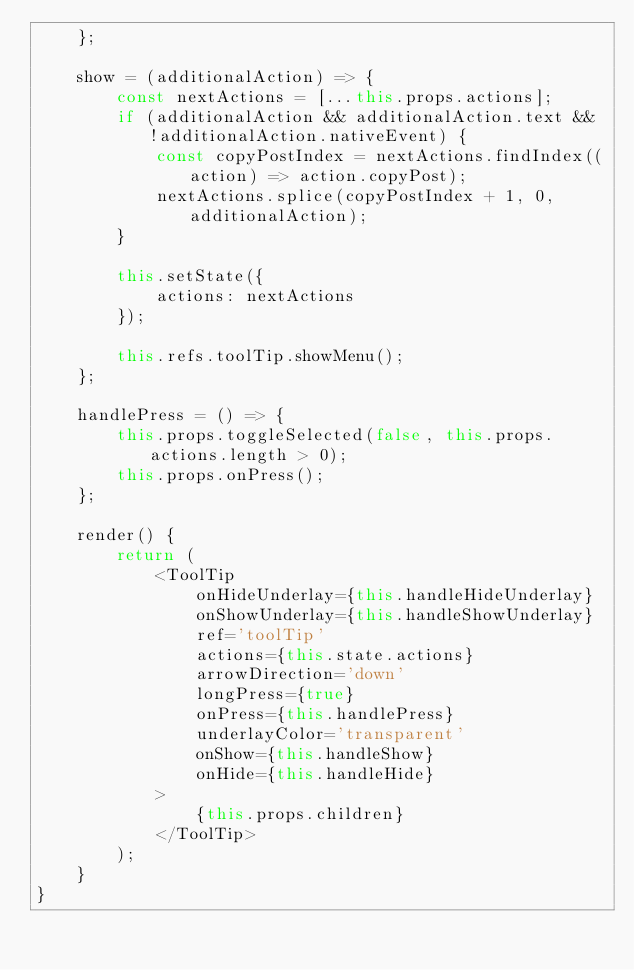<code> <loc_0><loc_0><loc_500><loc_500><_JavaScript_>    };

    show = (additionalAction) => {
        const nextActions = [...this.props.actions];
        if (additionalAction && additionalAction.text && !additionalAction.nativeEvent) {
            const copyPostIndex = nextActions.findIndex((action) => action.copyPost);
            nextActions.splice(copyPostIndex + 1, 0, additionalAction);
        }

        this.setState({
            actions: nextActions
        });

        this.refs.toolTip.showMenu();
    };

    handlePress = () => {
        this.props.toggleSelected(false, this.props.actions.length > 0);
        this.props.onPress();
    };

    render() {
        return (
            <ToolTip
                onHideUnderlay={this.handleHideUnderlay}
                onShowUnderlay={this.handleShowUnderlay}
                ref='toolTip'
                actions={this.state.actions}
                arrowDirection='down'
                longPress={true}
                onPress={this.handlePress}
                underlayColor='transparent'
                onShow={this.handleShow}
                onHide={this.handleHide}
            >
                {this.props.children}
            </ToolTip>
        );
    }
}
</code> 